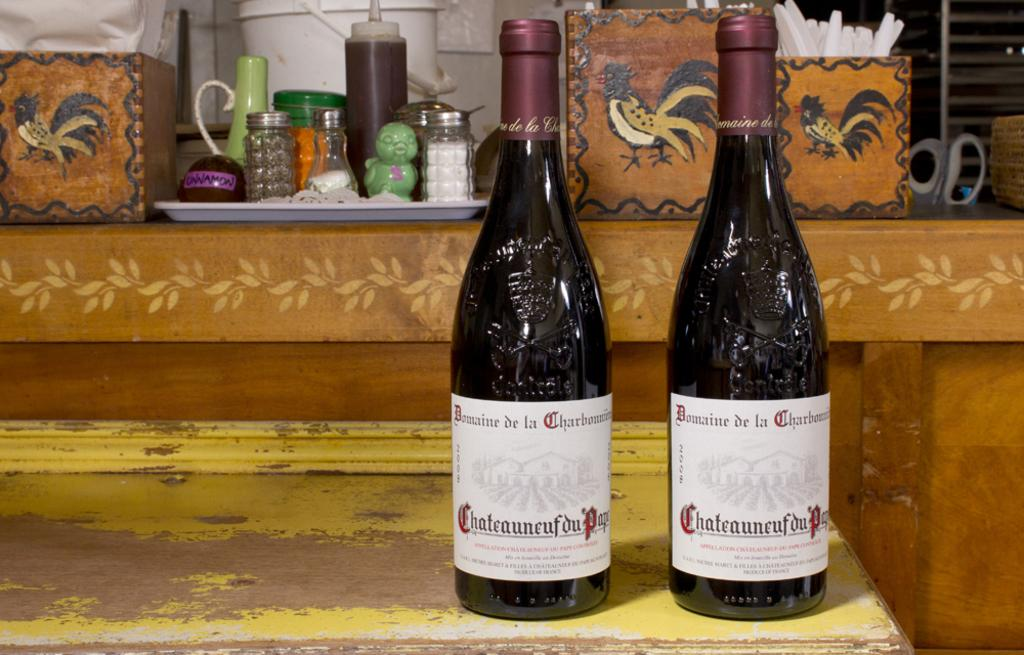<image>
Relay a brief, clear account of the picture shown. Two bottles of a wine with the labels that says "Domaine de" something are on a worn yellow table in front of condiments. 